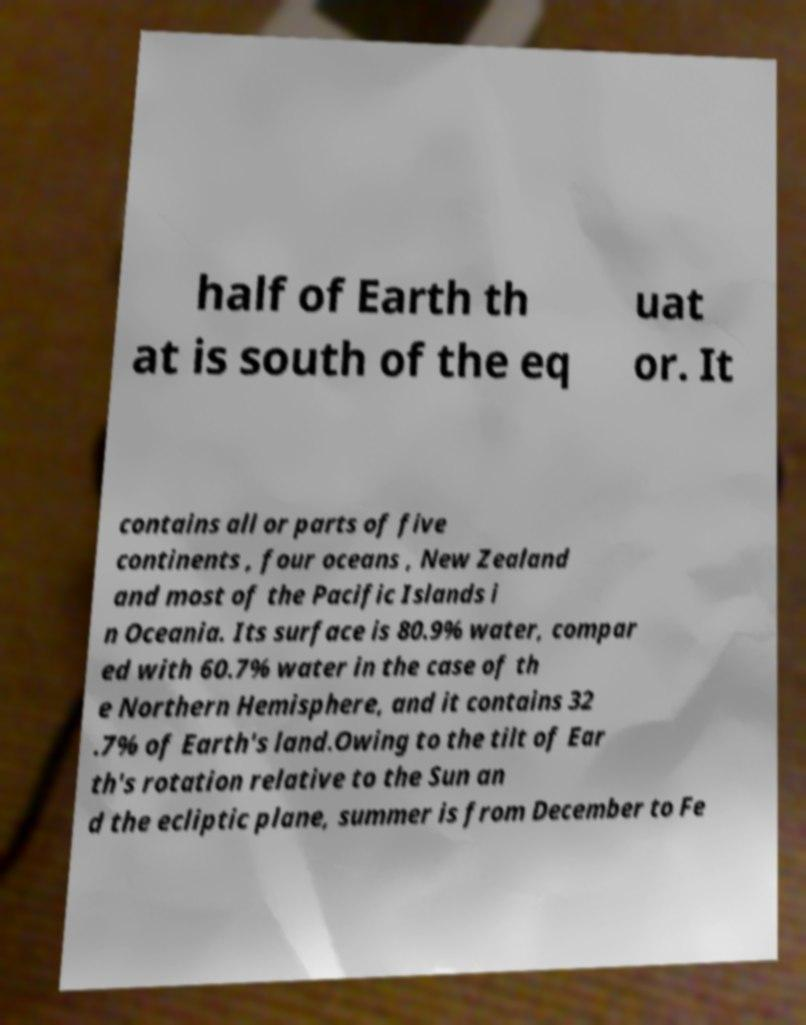Please identify and transcribe the text found in this image. half of Earth th at is south of the eq uat or. It contains all or parts of five continents , four oceans , New Zealand and most of the Pacific Islands i n Oceania. Its surface is 80.9% water, compar ed with 60.7% water in the case of th e Northern Hemisphere, and it contains 32 .7% of Earth's land.Owing to the tilt of Ear th's rotation relative to the Sun an d the ecliptic plane, summer is from December to Fe 